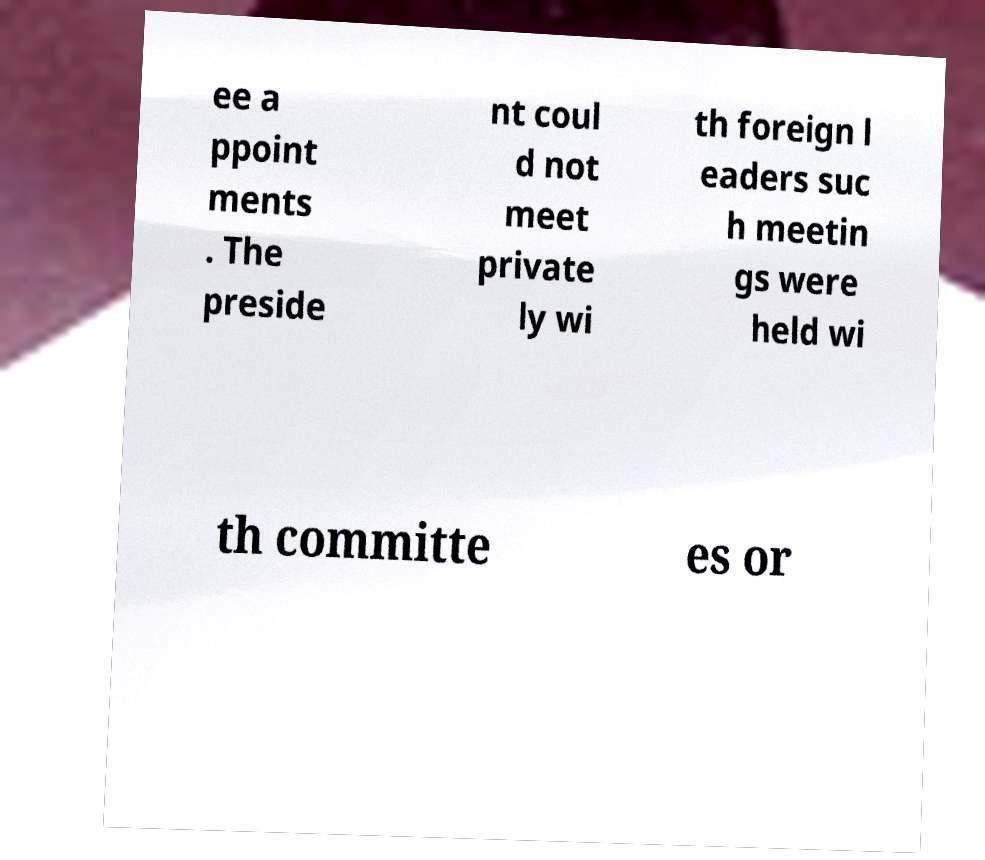Please read and relay the text visible in this image. What does it say? ee a ppoint ments . The preside nt coul d not meet private ly wi th foreign l eaders suc h meetin gs were held wi th committe es or 